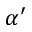Convert formula to latex. <formula><loc_0><loc_0><loc_500><loc_500>\alpha ^ { \prime }</formula> 